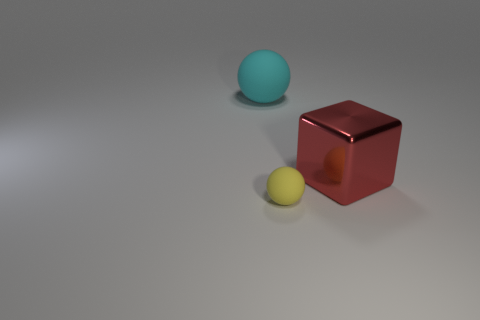There is a metal cube; is it the same size as the sphere behind the small object?
Your answer should be very brief. Yes. What color is the object that is behind the yellow thing and left of the red metal object?
Make the answer very short. Cyan. Are there more objects that are in front of the cyan thing than metal things that are in front of the tiny matte sphere?
Ensure brevity in your answer.  Yes. The other object that is the same material as the big cyan object is what size?
Your response must be concise. Small. What number of big cyan rubber things are right of the matte ball to the right of the large cyan ball?
Give a very brief answer. 0. Are there any yellow rubber things of the same shape as the cyan rubber object?
Provide a short and direct response. Yes. What color is the large object in front of the ball that is left of the yellow thing?
Provide a short and direct response. Red. Is the number of matte spheres greater than the number of big shiny blocks?
Give a very brief answer. Yes. How many gray shiny balls are the same size as the red cube?
Provide a succinct answer. 0. Do the cyan thing and the large thing that is on the right side of the large cyan matte sphere have the same material?
Keep it short and to the point. No. 